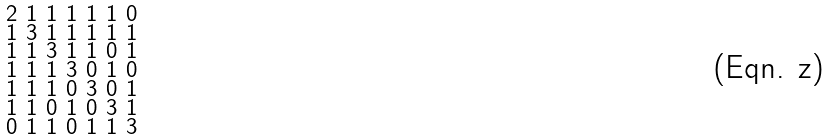Convert formula to latex. <formula><loc_0><loc_0><loc_500><loc_500>\begin{smallmatrix} 2 & 1 & 1 & 1 & 1 & 1 & 0 \\ 1 & 3 & 1 & 1 & 1 & 1 & 1 \\ 1 & 1 & 3 & 1 & 1 & 0 & 1 \\ 1 & 1 & 1 & 3 & 0 & 1 & 0 \\ 1 & 1 & 1 & 0 & 3 & 0 & 1 \\ 1 & 1 & 0 & 1 & 0 & 3 & 1 \\ 0 & 1 & 1 & 0 & 1 & 1 & 3 \end{smallmatrix}</formula> 